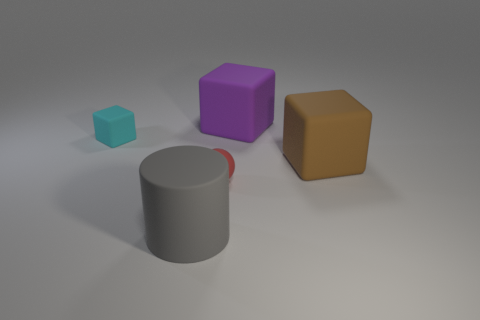Subtract all large cubes. How many cubes are left? 1 Add 1 big brown things. How many objects exist? 6 Subtract all purple cubes. How many cubes are left? 2 Subtract all balls. How many objects are left? 4 Add 1 red rubber objects. How many red rubber objects exist? 2 Subtract 1 gray cylinders. How many objects are left? 4 Subtract all cyan cylinders. Subtract all yellow blocks. How many cylinders are left? 1 Subtract all cubes. Subtract all small rubber spheres. How many objects are left? 1 Add 2 big brown cubes. How many big brown cubes are left? 3 